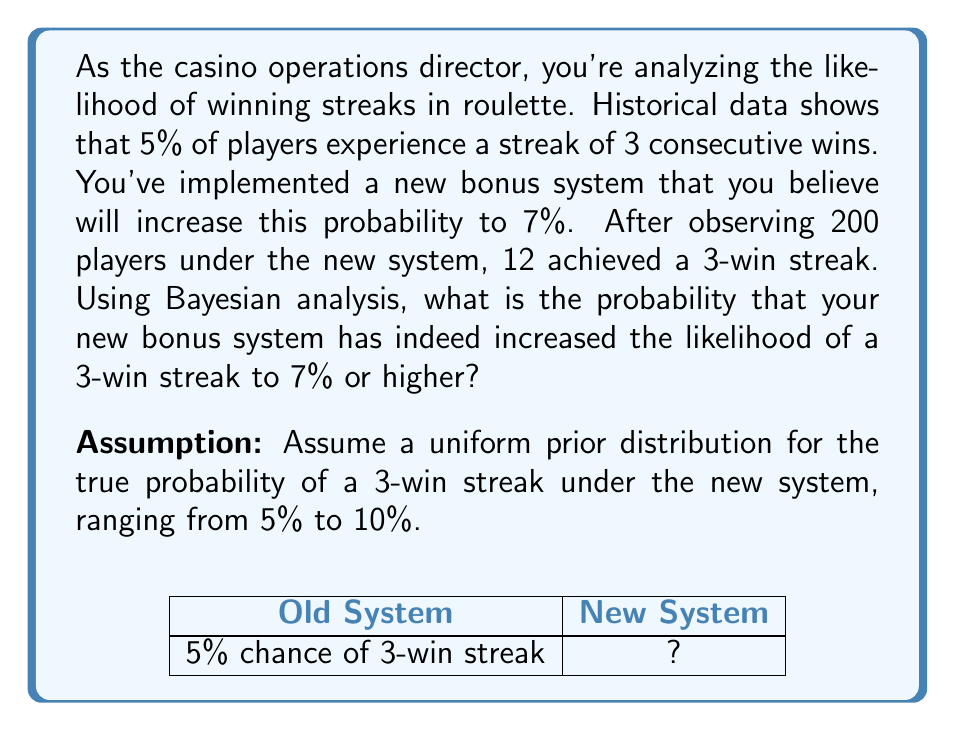Provide a solution to this math problem. Let's approach this step-by-step using Bayesian analysis:

1) Define our hypotheses:
   $H_0$: The probability is still 5% (old system)
   $H_1$: The probability has increased to 7% or higher (new system)

2) Set up the prior probabilities:
   Given the uniform prior from 5% to 10%, the probability of $H_1$ is:
   $P(H_1) = \frac{10\% - 7\%}{10\% - 5\%} = 0.6$
   $P(H_0) = 1 - P(H_1) = 0.4$

3) Calculate the likelihood of observing 12 successes in 200 trials:
   For $H_0$: $P(D|H_0) = \binom{200}{12} (0.05)^{12} (0.95)^{188}$
   For $H_1$: We'll use the average probability for $H_1$, which is 8.5%
              $P(D|H_1) = \binom{200}{12} (0.085)^{12} (0.915)^{188}$

4) Apply Bayes' theorem:
   $$P(H_1|D) = \frac{P(D|H_1)P(H_1)}{P(D|H_1)P(H_1) + P(D|H_0)P(H_0)}$$

5) Calculate the probabilities:
   $P(D|H_0) \approx 0.0098$
   $P(D|H_1) \approx 0.0456$

6) Plug into Bayes' theorem:
   $$P(H_1|D) = \frac{0.0456 * 0.6}{0.0456 * 0.6 + 0.0098 * 0.4} \approx 0.8747$$

Therefore, the probability that the new bonus system has increased the likelihood of a 3-win streak to 7% or higher is approximately 0.8747 or 87.47%.
Answer: 0.8747 (or 87.47%) 